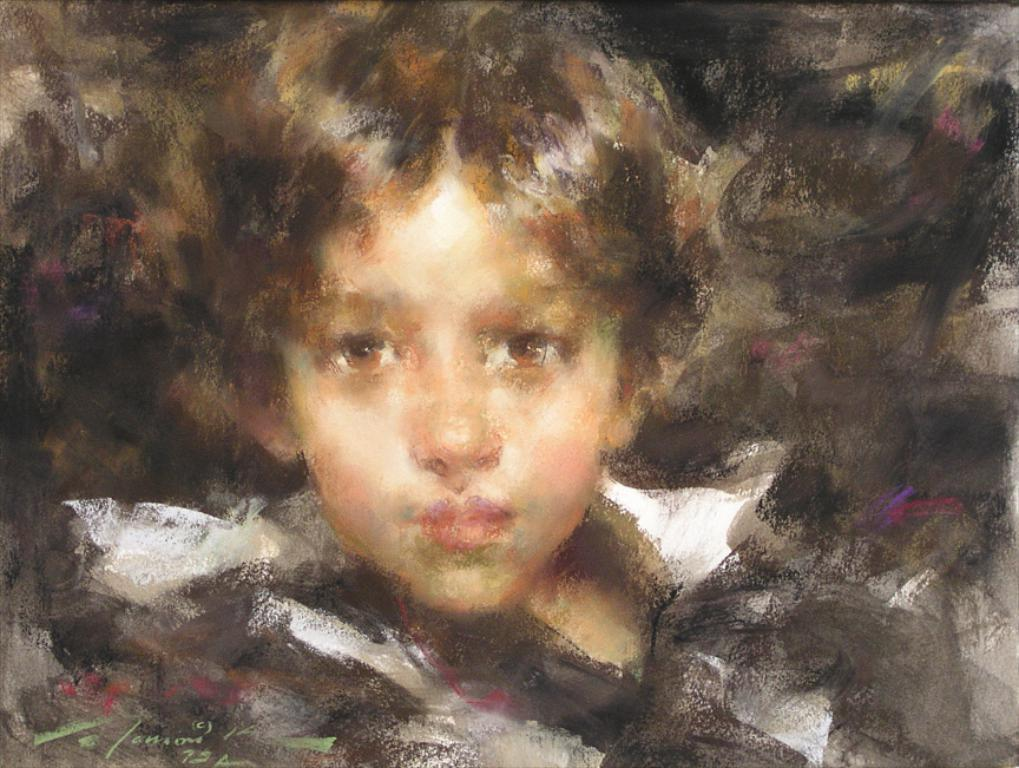What type of artwork is shown in the image? The image is a painted picture. What is the main subject of the painted picture? The picture depicts a person. What type of table is visible in the image? There is no table present in the image; it is a painted picture of a person. What drink is the person holding in the image? There is no drink visible in the image, as it is a painted picture of a person without any additional objects or context. 